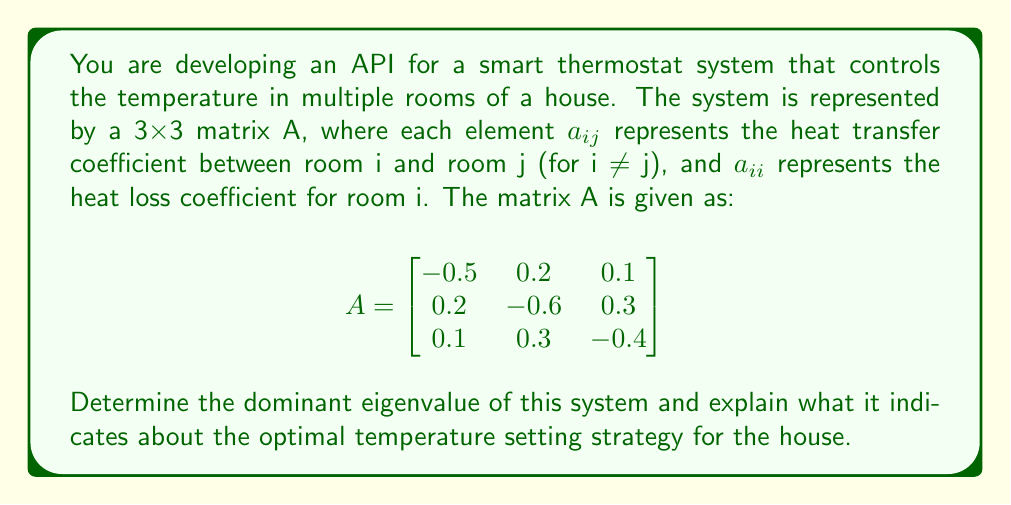Give your solution to this math problem. To solve this problem, we need to follow these steps:

1) First, we need to find the eigenvalues of the matrix A. The characteristic equation is given by:

   $$det(A - \lambda I) = 0$$

   Where I is the 3x3 identity matrix and λ represents the eigenvalues.

2) Expanding this, we get:

   $$(-0.5-\lambda)((-0.6-\lambda)(-0.4-\lambda) - 0.09) - 0.2(0.2(-0.4-\lambda) - 0.03) + 0.1(0.06 - 0.3(-0.6-\lambda)) = 0$$

3) Simplifying:

   $$-\lambda^3 - 1.5\lambda^2 - 0.71\lambda - 0.106 = 0$$

4) This cubic equation can be solved using numerical methods. The eigenvalues are approximately:

   $$\lambda_1 \approx -0.1815, \lambda_2 \approx -0.4592, \lambda_3 \approx -0.8593$$

5) The dominant eigenvalue is the one with the largest absolute value, which in this case is $\lambda_3 \approx -0.8593$.

6) In the context of a thermostat system:
   - Negative eigenvalues indicate a stable system where temperatures will converge over time.
   - The magnitude of the dominant eigenvalue represents the main rate of temperature change in the system.
   - A larger magnitude means faster convergence to the equilibrium temperature.

7) For API development, this information can be used to:
   - Predict how quickly the house will reach the desired temperature.
   - Optimize the frequency of temperature adjustments.
   - Implement more efficient heating/cooling cycles.
Answer: The dominant eigenvalue is approximately -0.8593. This indicates a stable system with relatively fast convergence to equilibrium temperatures. The API should be designed to make less frequent but more significant temperature adjustments, as the system will naturally stabilize quickly. 